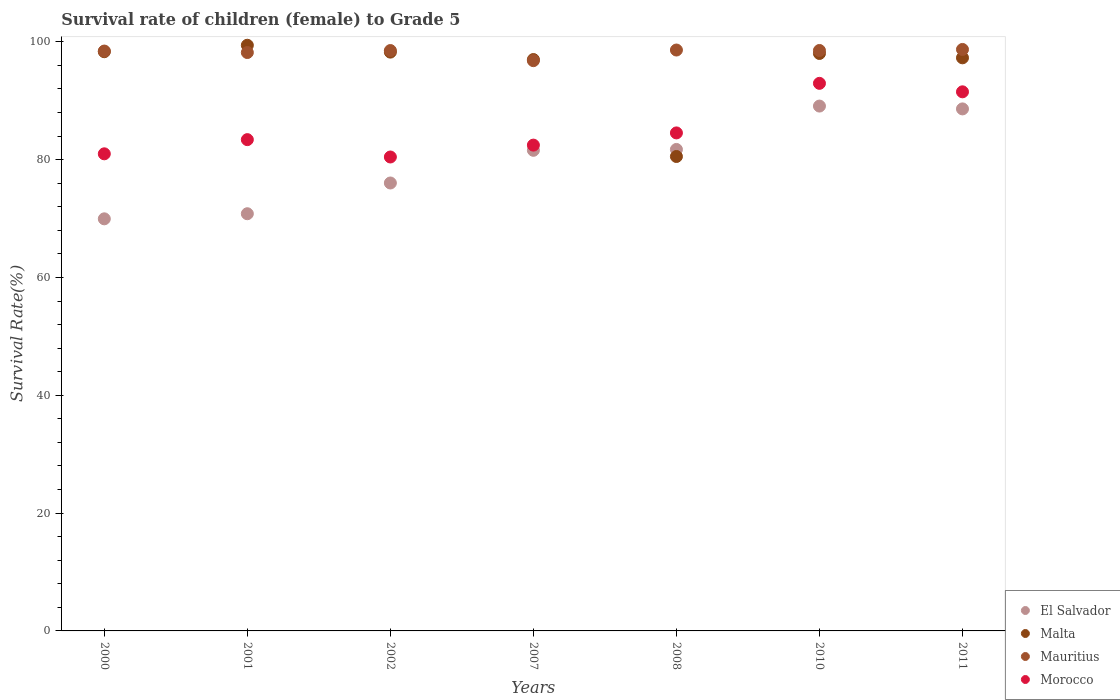How many different coloured dotlines are there?
Offer a terse response. 4. Is the number of dotlines equal to the number of legend labels?
Provide a short and direct response. Yes. What is the survival rate of female children to grade 5 in Mauritius in 2007?
Your response must be concise. 96.81. Across all years, what is the maximum survival rate of female children to grade 5 in Mauritius?
Ensure brevity in your answer.  98.71. Across all years, what is the minimum survival rate of female children to grade 5 in Morocco?
Provide a short and direct response. 80.45. In which year was the survival rate of female children to grade 5 in Malta minimum?
Your answer should be compact. 2008. What is the total survival rate of female children to grade 5 in Mauritius in the graph?
Give a very brief answer. 687.8. What is the difference between the survival rate of female children to grade 5 in Malta in 2000 and that in 2008?
Offer a terse response. 17.79. What is the difference between the survival rate of female children to grade 5 in Morocco in 2011 and the survival rate of female children to grade 5 in Malta in 2002?
Offer a very short reply. -6.74. What is the average survival rate of female children to grade 5 in Mauritius per year?
Make the answer very short. 98.26. In the year 2007, what is the difference between the survival rate of female children to grade 5 in El Salvador and survival rate of female children to grade 5 in Morocco?
Provide a short and direct response. -0.88. What is the ratio of the survival rate of female children to grade 5 in Mauritius in 2001 to that in 2008?
Give a very brief answer. 1. Is the difference between the survival rate of female children to grade 5 in El Salvador in 2007 and 2011 greater than the difference between the survival rate of female children to grade 5 in Morocco in 2007 and 2011?
Your response must be concise. Yes. What is the difference between the highest and the second highest survival rate of female children to grade 5 in Morocco?
Ensure brevity in your answer.  1.44. What is the difference between the highest and the lowest survival rate of female children to grade 5 in Malta?
Ensure brevity in your answer.  18.88. In how many years, is the survival rate of female children to grade 5 in Mauritius greater than the average survival rate of female children to grade 5 in Mauritius taken over all years?
Keep it short and to the point. 5. Is it the case that in every year, the sum of the survival rate of female children to grade 5 in Mauritius and survival rate of female children to grade 5 in El Salvador  is greater than the survival rate of female children to grade 5 in Malta?
Give a very brief answer. Yes. Is the survival rate of female children to grade 5 in Malta strictly greater than the survival rate of female children to grade 5 in Morocco over the years?
Offer a terse response. No. Is the survival rate of female children to grade 5 in Mauritius strictly less than the survival rate of female children to grade 5 in Morocco over the years?
Your answer should be compact. No. What is the difference between two consecutive major ticks on the Y-axis?
Ensure brevity in your answer.  20. Are the values on the major ticks of Y-axis written in scientific E-notation?
Ensure brevity in your answer.  No. Does the graph contain any zero values?
Keep it short and to the point. No. Where does the legend appear in the graph?
Your answer should be very brief. Bottom right. How many legend labels are there?
Make the answer very short. 4. What is the title of the graph?
Keep it short and to the point. Survival rate of children (female) to Grade 5. Does "Malawi" appear as one of the legend labels in the graph?
Your answer should be compact. No. What is the label or title of the X-axis?
Make the answer very short. Years. What is the label or title of the Y-axis?
Your answer should be compact. Survival Rate(%). What is the Survival Rate(%) in El Salvador in 2000?
Give a very brief answer. 69.95. What is the Survival Rate(%) in Malta in 2000?
Your answer should be compact. 98.32. What is the Survival Rate(%) in Mauritius in 2000?
Make the answer very short. 98.44. What is the Survival Rate(%) in Morocco in 2000?
Provide a succinct answer. 80.99. What is the Survival Rate(%) of El Salvador in 2001?
Provide a succinct answer. 70.82. What is the Survival Rate(%) in Malta in 2001?
Provide a succinct answer. 99.42. What is the Survival Rate(%) in Mauritius in 2001?
Your answer should be very brief. 98.19. What is the Survival Rate(%) in Morocco in 2001?
Offer a very short reply. 83.4. What is the Survival Rate(%) of El Salvador in 2002?
Ensure brevity in your answer.  76.04. What is the Survival Rate(%) of Malta in 2002?
Your response must be concise. 98.26. What is the Survival Rate(%) of Mauritius in 2002?
Give a very brief answer. 98.52. What is the Survival Rate(%) in Morocco in 2002?
Your response must be concise. 80.45. What is the Survival Rate(%) in El Salvador in 2007?
Provide a short and direct response. 81.59. What is the Survival Rate(%) of Malta in 2007?
Provide a succinct answer. 97. What is the Survival Rate(%) of Mauritius in 2007?
Make the answer very short. 96.81. What is the Survival Rate(%) of Morocco in 2007?
Make the answer very short. 82.47. What is the Survival Rate(%) in El Salvador in 2008?
Your answer should be very brief. 81.73. What is the Survival Rate(%) in Malta in 2008?
Provide a succinct answer. 80.54. What is the Survival Rate(%) in Mauritius in 2008?
Provide a succinct answer. 98.61. What is the Survival Rate(%) in Morocco in 2008?
Give a very brief answer. 84.54. What is the Survival Rate(%) in El Salvador in 2010?
Your answer should be very brief. 89.1. What is the Survival Rate(%) in Malta in 2010?
Your answer should be very brief. 98.03. What is the Survival Rate(%) in Mauritius in 2010?
Your response must be concise. 98.53. What is the Survival Rate(%) of Morocco in 2010?
Give a very brief answer. 92.95. What is the Survival Rate(%) of El Salvador in 2011?
Provide a short and direct response. 88.62. What is the Survival Rate(%) of Malta in 2011?
Ensure brevity in your answer.  97.29. What is the Survival Rate(%) in Mauritius in 2011?
Provide a succinct answer. 98.71. What is the Survival Rate(%) in Morocco in 2011?
Keep it short and to the point. 91.52. Across all years, what is the maximum Survival Rate(%) of El Salvador?
Your answer should be very brief. 89.1. Across all years, what is the maximum Survival Rate(%) of Malta?
Your answer should be very brief. 99.42. Across all years, what is the maximum Survival Rate(%) in Mauritius?
Your answer should be compact. 98.71. Across all years, what is the maximum Survival Rate(%) in Morocco?
Make the answer very short. 92.95. Across all years, what is the minimum Survival Rate(%) of El Salvador?
Provide a short and direct response. 69.95. Across all years, what is the minimum Survival Rate(%) in Malta?
Offer a very short reply. 80.54. Across all years, what is the minimum Survival Rate(%) in Mauritius?
Provide a succinct answer. 96.81. Across all years, what is the minimum Survival Rate(%) of Morocco?
Make the answer very short. 80.45. What is the total Survival Rate(%) of El Salvador in the graph?
Offer a very short reply. 557.84. What is the total Survival Rate(%) of Malta in the graph?
Your answer should be very brief. 668.84. What is the total Survival Rate(%) of Mauritius in the graph?
Keep it short and to the point. 687.8. What is the total Survival Rate(%) of Morocco in the graph?
Your answer should be compact. 596.32. What is the difference between the Survival Rate(%) of El Salvador in 2000 and that in 2001?
Ensure brevity in your answer.  -0.87. What is the difference between the Survival Rate(%) of Malta in 2000 and that in 2001?
Provide a succinct answer. -1.1. What is the difference between the Survival Rate(%) of Mauritius in 2000 and that in 2001?
Provide a short and direct response. 0.25. What is the difference between the Survival Rate(%) in Morocco in 2000 and that in 2001?
Your response must be concise. -2.41. What is the difference between the Survival Rate(%) of El Salvador in 2000 and that in 2002?
Your answer should be very brief. -6.08. What is the difference between the Survival Rate(%) of Malta in 2000 and that in 2002?
Provide a short and direct response. 0.07. What is the difference between the Survival Rate(%) in Mauritius in 2000 and that in 2002?
Offer a terse response. -0.09. What is the difference between the Survival Rate(%) of Morocco in 2000 and that in 2002?
Keep it short and to the point. 0.54. What is the difference between the Survival Rate(%) of El Salvador in 2000 and that in 2007?
Your answer should be compact. -11.63. What is the difference between the Survival Rate(%) of Malta in 2000 and that in 2007?
Provide a short and direct response. 1.33. What is the difference between the Survival Rate(%) of Mauritius in 2000 and that in 2007?
Your answer should be very brief. 1.63. What is the difference between the Survival Rate(%) in Morocco in 2000 and that in 2007?
Make the answer very short. -1.48. What is the difference between the Survival Rate(%) in El Salvador in 2000 and that in 2008?
Offer a terse response. -11.78. What is the difference between the Survival Rate(%) in Malta in 2000 and that in 2008?
Make the answer very short. 17.79. What is the difference between the Survival Rate(%) in Mauritius in 2000 and that in 2008?
Your answer should be very brief. -0.17. What is the difference between the Survival Rate(%) in Morocco in 2000 and that in 2008?
Provide a succinct answer. -3.55. What is the difference between the Survival Rate(%) of El Salvador in 2000 and that in 2010?
Ensure brevity in your answer.  -19.14. What is the difference between the Survival Rate(%) in Malta in 2000 and that in 2010?
Your answer should be compact. 0.3. What is the difference between the Survival Rate(%) in Mauritius in 2000 and that in 2010?
Offer a very short reply. -0.1. What is the difference between the Survival Rate(%) of Morocco in 2000 and that in 2010?
Ensure brevity in your answer.  -11.96. What is the difference between the Survival Rate(%) in El Salvador in 2000 and that in 2011?
Ensure brevity in your answer.  -18.66. What is the difference between the Survival Rate(%) of Malta in 2000 and that in 2011?
Provide a short and direct response. 1.04. What is the difference between the Survival Rate(%) of Mauritius in 2000 and that in 2011?
Offer a terse response. -0.27. What is the difference between the Survival Rate(%) in Morocco in 2000 and that in 2011?
Make the answer very short. -10.52. What is the difference between the Survival Rate(%) in El Salvador in 2001 and that in 2002?
Offer a terse response. -5.22. What is the difference between the Survival Rate(%) in Malta in 2001 and that in 2002?
Offer a very short reply. 1.16. What is the difference between the Survival Rate(%) in Mauritius in 2001 and that in 2002?
Provide a short and direct response. -0.34. What is the difference between the Survival Rate(%) of Morocco in 2001 and that in 2002?
Your response must be concise. 2.95. What is the difference between the Survival Rate(%) in El Salvador in 2001 and that in 2007?
Provide a short and direct response. -10.77. What is the difference between the Survival Rate(%) of Malta in 2001 and that in 2007?
Your answer should be very brief. 2.42. What is the difference between the Survival Rate(%) of Mauritius in 2001 and that in 2007?
Offer a terse response. 1.38. What is the difference between the Survival Rate(%) of Morocco in 2001 and that in 2007?
Give a very brief answer. 0.93. What is the difference between the Survival Rate(%) in El Salvador in 2001 and that in 2008?
Offer a terse response. -10.91. What is the difference between the Survival Rate(%) of Malta in 2001 and that in 2008?
Your response must be concise. 18.88. What is the difference between the Survival Rate(%) in Mauritius in 2001 and that in 2008?
Provide a short and direct response. -0.42. What is the difference between the Survival Rate(%) of Morocco in 2001 and that in 2008?
Keep it short and to the point. -1.14. What is the difference between the Survival Rate(%) of El Salvador in 2001 and that in 2010?
Provide a short and direct response. -18.28. What is the difference between the Survival Rate(%) in Malta in 2001 and that in 2010?
Make the answer very short. 1.4. What is the difference between the Survival Rate(%) in Mauritius in 2001 and that in 2010?
Give a very brief answer. -0.35. What is the difference between the Survival Rate(%) of Morocco in 2001 and that in 2010?
Provide a short and direct response. -9.56. What is the difference between the Survival Rate(%) in El Salvador in 2001 and that in 2011?
Keep it short and to the point. -17.8. What is the difference between the Survival Rate(%) of Malta in 2001 and that in 2011?
Keep it short and to the point. 2.13. What is the difference between the Survival Rate(%) in Mauritius in 2001 and that in 2011?
Ensure brevity in your answer.  -0.52. What is the difference between the Survival Rate(%) in Morocco in 2001 and that in 2011?
Your answer should be very brief. -8.12. What is the difference between the Survival Rate(%) in El Salvador in 2002 and that in 2007?
Offer a terse response. -5.55. What is the difference between the Survival Rate(%) in Malta in 2002 and that in 2007?
Your response must be concise. 1.26. What is the difference between the Survival Rate(%) of Mauritius in 2002 and that in 2007?
Provide a short and direct response. 1.72. What is the difference between the Survival Rate(%) in Morocco in 2002 and that in 2007?
Ensure brevity in your answer.  -2.02. What is the difference between the Survival Rate(%) in El Salvador in 2002 and that in 2008?
Ensure brevity in your answer.  -5.69. What is the difference between the Survival Rate(%) of Malta in 2002 and that in 2008?
Your answer should be very brief. 17.72. What is the difference between the Survival Rate(%) in Mauritius in 2002 and that in 2008?
Your answer should be very brief. -0.09. What is the difference between the Survival Rate(%) of Morocco in 2002 and that in 2008?
Offer a terse response. -4.09. What is the difference between the Survival Rate(%) in El Salvador in 2002 and that in 2010?
Your answer should be very brief. -13.06. What is the difference between the Survival Rate(%) of Malta in 2002 and that in 2010?
Offer a terse response. 0.23. What is the difference between the Survival Rate(%) in Mauritius in 2002 and that in 2010?
Give a very brief answer. -0.01. What is the difference between the Survival Rate(%) of Morocco in 2002 and that in 2010?
Offer a terse response. -12.5. What is the difference between the Survival Rate(%) in El Salvador in 2002 and that in 2011?
Provide a short and direct response. -12.58. What is the difference between the Survival Rate(%) of Malta in 2002 and that in 2011?
Offer a terse response. 0.97. What is the difference between the Survival Rate(%) in Mauritius in 2002 and that in 2011?
Provide a short and direct response. -0.19. What is the difference between the Survival Rate(%) of Morocco in 2002 and that in 2011?
Make the answer very short. -11.06. What is the difference between the Survival Rate(%) in El Salvador in 2007 and that in 2008?
Keep it short and to the point. -0.15. What is the difference between the Survival Rate(%) of Malta in 2007 and that in 2008?
Your answer should be compact. 16.46. What is the difference between the Survival Rate(%) in Mauritius in 2007 and that in 2008?
Your answer should be very brief. -1.8. What is the difference between the Survival Rate(%) of Morocco in 2007 and that in 2008?
Keep it short and to the point. -2.07. What is the difference between the Survival Rate(%) of El Salvador in 2007 and that in 2010?
Give a very brief answer. -7.51. What is the difference between the Survival Rate(%) of Malta in 2007 and that in 2010?
Your answer should be compact. -1.03. What is the difference between the Survival Rate(%) in Mauritius in 2007 and that in 2010?
Provide a short and direct response. -1.73. What is the difference between the Survival Rate(%) in Morocco in 2007 and that in 2010?
Offer a terse response. -10.49. What is the difference between the Survival Rate(%) of El Salvador in 2007 and that in 2011?
Your answer should be compact. -7.03. What is the difference between the Survival Rate(%) in Malta in 2007 and that in 2011?
Provide a succinct answer. -0.29. What is the difference between the Survival Rate(%) in Mauritius in 2007 and that in 2011?
Your answer should be very brief. -1.9. What is the difference between the Survival Rate(%) of Morocco in 2007 and that in 2011?
Provide a short and direct response. -9.05. What is the difference between the Survival Rate(%) of El Salvador in 2008 and that in 2010?
Keep it short and to the point. -7.36. What is the difference between the Survival Rate(%) of Malta in 2008 and that in 2010?
Give a very brief answer. -17.49. What is the difference between the Survival Rate(%) of Mauritius in 2008 and that in 2010?
Your response must be concise. 0.08. What is the difference between the Survival Rate(%) in Morocco in 2008 and that in 2010?
Offer a terse response. -8.42. What is the difference between the Survival Rate(%) of El Salvador in 2008 and that in 2011?
Make the answer very short. -6.88. What is the difference between the Survival Rate(%) in Malta in 2008 and that in 2011?
Your answer should be compact. -16.75. What is the difference between the Survival Rate(%) in Mauritius in 2008 and that in 2011?
Keep it short and to the point. -0.1. What is the difference between the Survival Rate(%) in Morocco in 2008 and that in 2011?
Your response must be concise. -6.98. What is the difference between the Survival Rate(%) in El Salvador in 2010 and that in 2011?
Give a very brief answer. 0.48. What is the difference between the Survival Rate(%) of Malta in 2010 and that in 2011?
Keep it short and to the point. 0.74. What is the difference between the Survival Rate(%) in Mauritius in 2010 and that in 2011?
Your answer should be very brief. -0.17. What is the difference between the Survival Rate(%) in Morocco in 2010 and that in 2011?
Provide a short and direct response. 1.44. What is the difference between the Survival Rate(%) of El Salvador in 2000 and the Survival Rate(%) of Malta in 2001?
Provide a succinct answer. -29.47. What is the difference between the Survival Rate(%) of El Salvador in 2000 and the Survival Rate(%) of Mauritius in 2001?
Give a very brief answer. -28.23. What is the difference between the Survival Rate(%) of El Salvador in 2000 and the Survival Rate(%) of Morocco in 2001?
Keep it short and to the point. -13.44. What is the difference between the Survival Rate(%) in Malta in 2000 and the Survival Rate(%) in Mauritius in 2001?
Your response must be concise. 0.14. What is the difference between the Survival Rate(%) in Malta in 2000 and the Survival Rate(%) in Morocco in 2001?
Offer a terse response. 14.92. What is the difference between the Survival Rate(%) of Mauritius in 2000 and the Survival Rate(%) of Morocco in 2001?
Your answer should be very brief. 15.04. What is the difference between the Survival Rate(%) in El Salvador in 2000 and the Survival Rate(%) in Malta in 2002?
Your response must be concise. -28.3. What is the difference between the Survival Rate(%) in El Salvador in 2000 and the Survival Rate(%) in Mauritius in 2002?
Keep it short and to the point. -28.57. What is the difference between the Survival Rate(%) in El Salvador in 2000 and the Survival Rate(%) in Morocco in 2002?
Give a very brief answer. -10.5. What is the difference between the Survival Rate(%) of Malta in 2000 and the Survival Rate(%) of Mauritius in 2002?
Provide a succinct answer. -0.2. What is the difference between the Survival Rate(%) in Malta in 2000 and the Survival Rate(%) in Morocco in 2002?
Your answer should be compact. 17.87. What is the difference between the Survival Rate(%) in Mauritius in 2000 and the Survival Rate(%) in Morocco in 2002?
Provide a succinct answer. 17.98. What is the difference between the Survival Rate(%) in El Salvador in 2000 and the Survival Rate(%) in Malta in 2007?
Your answer should be compact. -27.04. What is the difference between the Survival Rate(%) of El Salvador in 2000 and the Survival Rate(%) of Mauritius in 2007?
Provide a short and direct response. -26.85. What is the difference between the Survival Rate(%) of El Salvador in 2000 and the Survival Rate(%) of Morocco in 2007?
Your answer should be compact. -12.51. What is the difference between the Survival Rate(%) of Malta in 2000 and the Survival Rate(%) of Mauritius in 2007?
Your answer should be compact. 1.52. What is the difference between the Survival Rate(%) in Malta in 2000 and the Survival Rate(%) in Morocco in 2007?
Your response must be concise. 15.86. What is the difference between the Survival Rate(%) in Mauritius in 2000 and the Survival Rate(%) in Morocco in 2007?
Your answer should be compact. 15.97. What is the difference between the Survival Rate(%) of El Salvador in 2000 and the Survival Rate(%) of Malta in 2008?
Ensure brevity in your answer.  -10.58. What is the difference between the Survival Rate(%) of El Salvador in 2000 and the Survival Rate(%) of Mauritius in 2008?
Give a very brief answer. -28.65. What is the difference between the Survival Rate(%) of El Salvador in 2000 and the Survival Rate(%) of Morocco in 2008?
Keep it short and to the point. -14.58. What is the difference between the Survival Rate(%) in Malta in 2000 and the Survival Rate(%) in Mauritius in 2008?
Provide a succinct answer. -0.29. What is the difference between the Survival Rate(%) in Malta in 2000 and the Survival Rate(%) in Morocco in 2008?
Give a very brief answer. 13.78. What is the difference between the Survival Rate(%) in Mauritius in 2000 and the Survival Rate(%) in Morocco in 2008?
Give a very brief answer. 13.9. What is the difference between the Survival Rate(%) of El Salvador in 2000 and the Survival Rate(%) of Malta in 2010?
Make the answer very short. -28.07. What is the difference between the Survival Rate(%) of El Salvador in 2000 and the Survival Rate(%) of Mauritius in 2010?
Your answer should be very brief. -28.58. What is the difference between the Survival Rate(%) of El Salvador in 2000 and the Survival Rate(%) of Morocco in 2010?
Provide a succinct answer. -23. What is the difference between the Survival Rate(%) of Malta in 2000 and the Survival Rate(%) of Mauritius in 2010?
Offer a very short reply. -0.21. What is the difference between the Survival Rate(%) of Malta in 2000 and the Survival Rate(%) of Morocco in 2010?
Make the answer very short. 5.37. What is the difference between the Survival Rate(%) of Mauritius in 2000 and the Survival Rate(%) of Morocco in 2010?
Your answer should be compact. 5.48. What is the difference between the Survival Rate(%) of El Salvador in 2000 and the Survival Rate(%) of Malta in 2011?
Make the answer very short. -27.33. What is the difference between the Survival Rate(%) of El Salvador in 2000 and the Survival Rate(%) of Mauritius in 2011?
Ensure brevity in your answer.  -28.75. What is the difference between the Survival Rate(%) of El Salvador in 2000 and the Survival Rate(%) of Morocco in 2011?
Provide a short and direct response. -21.56. What is the difference between the Survival Rate(%) of Malta in 2000 and the Survival Rate(%) of Mauritius in 2011?
Provide a succinct answer. -0.38. What is the difference between the Survival Rate(%) of Malta in 2000 and the Survival Rate(%) of Morocco in 2011?
Your response must be concise. 6.81. What is the difference between the Survival Rate(%) of Mauritius in 2000 and the Survival Rate(%) of Morocco in 2011?
Offer a terse response. 6.92. What is the difference between the Survival Rate(%) in El Salvador in 2001 and the Survival Rate(%) in Malta in 2002?
Provide a short and direct response. -27.44. What is the difference between the Survival Rate(%) in El Salvador in 2001 and the Survival Rate(%) in Mauritius in 2002?
Offer a terse response. -27.7. What is the difference between the Survival Rate(%) in El Salvador in 2001 and the Survival Rate(%) in Morocco in 2002?
Offer a very short reply. -9.63. What is the difference between the Survival Rate(%) of Malta in 2001 and the Survival Rate(%) of Mauritius in 2002?
Keep it short and to the point. 0.9. What is the difference between the Survival Rate(%) of Malta in 2001 and the Survival Rate(%) of Morocco in 2002?
Keep it short and to the point. 18.97. What is the difference between the Survival Rate(%) in Mauritius in 2001 and the Survival Rate(%) in Morocco in 2002?
Offer a terse response. 17.73. What is the difference between the Survival Rate(%) of El Salvador in 2001 and the Survival Rate(%) of Malta in 2007?
Provide a short and direct response. -26.18. What is the difference between the Survival Rate(%) in El Salvador in 2001 and the Survival Rate(%) in Mauritius in 2007?
Your response must be concise. -25.99. What is the difference between the Survival Rate(%) in El Salvador in 2001 and the Survival Rate(%) in Morocco in 2007?
Your answer should be very brief. -11.65. What is the difference between the Survival Rate(%) of Malta in 2001 and the Survival Rate(%) of Mauritius in 2007?
Your response must be concise. 2.61. What is the difference between the Survival Rate(%) in Malta in 2001 and the Survival Rate(%) in Morocco in 2007?
Provide a short and direct response. 16.95. What is the difference between the Survival Rate(%) in Mauritius in 2001 and the Survival Rate(%) in Morocco in 2007?
Your answer should be very brief. 15.72. What is the difference between the Survival Rate(%) of El Salvador in 2001 and the Survival Rate(%) of Malta in 2008?
Your answer should be compact. -9.72. What is the difference between the Survival Rate(%) of El Salvador in 2001 and the Survival Rate(%) of Mauritius in 2008?
Provide a succinct answer. -27.79. What is the difference between the Survival Rate(%) in El Salvador in 2001 and the Survival Rate(%) in Morocco in 2008?
Ensure brevity in your answer.  -13.72. What is the difference between the Survival Rate(%) of Malta in 2001 and the Survival Rate(%) of Mauritius in 2008?
Provide a succinct answer. 0.81. What is the difference between the Survival Rate(%) in Malta in 2001 and the Survival Rate(%) in Morocco in 2008?
Your response must be concise. 14.88. What is the difference between the Survival Rate(%) of Mauritius in 2001 and the Survival Rate(%) of Morocco in 2008?
Your answer should be compact. 13.65. What is the difference between the Survival Rate(%) in El Salvador in 2001 and the Survival Rate(%) in Malta in 2010?
Provide a succinct answer. -27.21. What is the difference between the Survival Rate(%) in El Salvador in 2001 and the Survival Rate(%) in Mauritius in 2010?
Give a very brief answer. -27.71. What is the difference between the Survival Rate(%) in El Salvador in 2001 and the Survival Rate(%) in Morocco in 2010?
Provide a succinct answer. -22.13. What is the difference between the Survival Rate(%) of Malta in 2001 and the Survival Rate(%) of Mauritius in 2010?
Give a very brief answer. 0.89. What is the difference between the Survival Rate(%) in Malta in 2001 and the Survival Rate(%) in Morocco in 2010?
Your answer should be compact. 6.47. What is the difference between the Survival Rate(%) in Mauritius in 2001 and the Survival Rate(%) in Morocco in 2010?
Your answer should be compact. 5.23. What is the difference between the Survival Rate(%) in El Salvador in 2001 and the Survival Rate(%) in Malta in 2011?
Offer a terse response. -26.47. What is the difference between the Survival Rate(%) of El Salvador in 2001 and the Survival Rate(%) of Mauritius in 2011?
Your response must be concise. -27.89. What is the difference between the Survival Rate(%) in El Salvador in 2001 and the Survival Rate(%) in Morocco in 2011?
Make the answer very short. -20.7. What is the difference between the Survival Rate(%) of Malta in 2001 and the Survival Rate(%) of Mauritius in 2011?
Ensure brevity in your answer.  0.71. What is the difference between the Survival Rate(%) in Malta in 2001 and the Survival Rate(%) in Morocco in 2011?
Provide a short and direct response. 7.91. What is the difference between the Survival Rate(%) in Mauritius in 2001 and the Survival Rate(%) in Morocco in 2011?
Provide a short and direct response. 6.67. What is the difference between the Survival Rate(%) of El Salvador in 2002 and the Survival Rate(%) of Malta in 2007?
Keep it short and to the point. -20.96. What is the difference between the Survival Rate(%) in El Salvador in 2002 and the Survival Rate(%) in Mauritius in 2007?
Your answer should be compact. -20.77. What is the difference between the Survival Rate(%) of El Salvador in 2002 and the Survival Rate(%) of Morocco in 2007?
Keep it short and to the point. -6.43. What is the difference between the Survival Rate(%) of Malta in 2002 and the Survival Rate(%) of Mauritius in 2007?
Offer a very short reply. 1.45. What is the difference between the Survival Rate(%) of Malta in 2002 and the Survival Rate(%) of Morocco in 2007?
Your answer should be very brief. 15.79. What is the difference between the Survival Rate(%) of Mauritius in 2002 and the Survival Rate(%) of Morocco in 2007?
Offer a terse response. 16.05. What is the difference between the Survival Rate(%) of El Salvador in 2002 and the Survival Rate(%) of Malta in 2008?
Make the answer very short. -4.5. What is the difference between the Survival Rate(%) in El Salvador in 2002 and the Survival Rate(%) in Mauritius in 2008?
Offer a terse response. -22.57. What is the difference between the Survival Rate(%) of El Salvador in 2002 and the Survival Rate(%) of Morocco in 2008?
Your answer should be compact. -8.5. What is the difference between the Survival Rate(%) in Malta in 2002 and the Survival Rate(%) in Mauritius in 2008?
Make the answer very short. -0.35. What is the difference between the Survival Rate(%) in Malta in 2002 and the Survival Rate(%) in Morocco in 2008?
Your answer should be very brief. 13.72. What is the difference between the Survival Rate(%) of Mauritius in 2002 and the Survival Rate(%) of Morocco in 2008?
Your answer should be very brief. 13.98. What is the difference between the Survival Rate(%) in El Salvador in 2002 and the Survival Rate(%) in Malta in 2010?
Ensure brevity in your answer.  -21.99. What is the difference between the Survival Rate(%) of El Salvador in 2002 and the Survival Rate(%) of Mauritius in 2010?
Make the answer very short. -22.5. What is the difference between the Survival Rate(%) of El Salvador in 2002 and the Survival Rate(%) of Morocco in 2010?
Ensure brevity in your answer.  -16.92. What is the difference between the Survival Rate(%) in Malta in 2002 and the Survival Rate(%) in Mauritius in 2010?
Your answer should be compact. -0.28. What is the difference between the Survival Rate(%) of Malta in 2002 and the Survival Rate(%) of Morocco in 2010?
Provide a short and direct response. 5.3. What is the difference between the Survival Rate(%) of Mauritius in 2002 and the Survival Rate(%) of Morocco in 2010?
Your response must be concise. 5.57. What is the difference between the Survival Rate(%) of El Salvador in 2002 and the Survival Rate(%) of Malta in 2011?
Keep it short and to the point. -21.25. What is the difference between the Survival Rate(%) in El Salvador in 2002 and the Survival Rate(%) in Mauritius in 2011?
Your answer should be compact. -22.67. What is the difference between the Survival Rate(%) in El Salvador in 2002 and the Survival Rate(%) in Morocco in 2011?
Offer a very short reply. -15.48. What is the difference between the Survival Rate(%) of Malta in 2002 and the Survival Rate(%) of Mauritius in 2011?
Your answer should be very brief. -0.45. What is the difference between the Survival Rate(%) of Malta in 2002 and the Survival Rate(%) of Morocco in 2011?
Your answer should be very brief. 6.74. What is the difference between the Survival Rate(%) in Mauritius in 2002 and the Survival Rate(%) in Morocco in 2011?
Provide a short and direct response. 7.01. What is the difference between the Survival Rate(%) of El Salvador in 2007 and the Survival Rate(%) of Malta in 2008?
Your answer should be compact. 1.05. What is the difference between the Survival Rate(%) of El Salvador in 2007 and the Survival Rate(%) of Mauritius in 2008?
Keep it short and to the point. -17.02. What is the difference between the Survival Rate(%) in El Salvador in 2007 and the Survival Rate(%) in Morocco in 2008?
Your answer should be very brief. -2.95. What is the difference between the Survival Rate(%) of Malta in 2007 and the Survival Rate(%) of Mauritius in 2008?
Offer a very short reply. -1.61. What is the difference between the Survival Rate(%) in Malta in 2007 and the Survival Rate(%) in Morocco in 2008?
Offer a very short reply. 12.46. What is the difference between the Survival Rate(%) in Mauritius in 2007 and the Survival Rate(%) in Morocco in 2008?
Make the answer very short. 12.27. What is the difference between the Survival Rate(%) in El Salvador in 2007 and the Survival Rate(%) in Malta in 2010?
Ensure brevity in your answer.  -16.44. What is the difference between the Survival Rate(%) of El Salvador in 2007 and the Survival Rate(%) of Mauritius in 2010?
Ensure brevity in your answer.  -16.95. What is the difference between the Survival Rate(%) of El Salvador in 2007 and the Survival Rate(%) of Morocco in 2010?
Provide a short and direct response. -11.37. What is the difference between the Survival Rate(%) of Malta in 2007 and the Survival Rate(%) of Mauritius in 2010?
Your response must be concise. -1.54. What is the difference between the Survival Rate(%) in Malta in 2007 and the Survival Rate(%) in Morocco in 2010?
Keep it short and to the point. 4.04. What is the difference between the Survival Rate(%) of Mauritius in 2007 and the Survival Rate(%) of Morocco in 2010?
Ensure brevity in your answer.  3.85. What is the difference between the Survival Rate(%) in El Salvador in 2007 and the Survival Rate(%) in Malta in 2011?
Keep it short and to the point. -15.7. What is the difference between the Survival Rate(%) in El Salvador in 2007 and the Survival Rate(%) in Mauritius in 2011?
Provide a short and direct response. -17.12. What is the difference between the Survival Rate(%) of El Salvador in 2007 and the Survival Rate(%) of Morocco in 2011?
Offer a very short reply. -9.93. What is the difference between the Survival Rate(%) of Malta in 2007 and the Survival Rate(%) of Mauritius in 2011?
Your answer should be compact. -1.71. What is the difference between the Survival Rate(%) of Malta in 2007 and the Survival Rate(%) of Morocco in 2011?
Make the answer very short. 5.48. What is the difference between the Survival Rate(%) of Mauritius in 2007 and the Survival Rate(%) of Morocco in 2011?
Your response must be concise. 5.29. What is the difference between the Survival Rate(%) of El Salvador in 2008 and the Survival Rate(%) of Malta in 2010?
Give a very brief answer. -16.29. What is the difference between the Survival Rate(%) of El Salvador in 2008 and the Survival Rate(%) of Mauritius in 2010?
Offer a terse response. -16.8. What is the difference between the Survival Rate(%) in El Salvador in 2008 and the Survival Rate(%) in Morocco in 2010?
Offer a very short reply. -11.22. What is the difference between the Survival Rate(%) of Malta in 2008 and the Survival Rate(%) of Mauritius in 2010?
Offer a very short reply. -18. What is the difference between the Survival Rate(%) in Malta in 2008 and the Survival Rate(%) in Morocco in 2010?
Provide a succinct answer. -12.42. What is the difference between the Survival Rate(%) of Mauritius in 2008 and the Survival Rate(%) of Morocco in 2010?
Your answer should be compact. 5.66. What is the difference between the Survival Rate(%) of El Salvador in 2008 and the Survival Rate(%) of Malta in 2011?
Make the answer very short. -15.55. What is the difference between the Survival Rate(%) in El Salvador in 2008 and the Survival Rate(%) in Mauritius in 2011?
Provide a succinct answer. -16.98. What is the difference between the Survival Rate(%) of El Salvador in 2008 and the Survival Rate(%) of Morocco in 2011?
Offer a very short reply. -9.78. What is the difference between the Survival Rate(%) in Malta in 2008 and the Survival Rate(%) in Mauritius in 2011?
Keep it short and to the point. -18.17. What is the difference between the Survival Rate(%) in Malta in 2008 and the Survival Rate(%) in Morocco in 2011?
Your answer should be very brief. -10.98. What is the difference between the Survival Rate(%) in Mauritius in 2008 and the Survival Rate(%) in Morocco in 2011?
Your response must be concise. 7.09. What is the difference between the Survival Rate(%) in El Salvador in 2010 and the Survival Rate(%) in Malta in 2011?
Provide a succinct answer. -8.19. What is the difference between the Survival Rate(%) in El Salvador in 2010 and the Survival Rate(%) in Mauritius in 2011?
Give a very brief answer. -9.61. What is the difference between the Survival Rate(%) of El Salvador in 2010 and the Survival Rate(%) of Morocco in 2011?
Your response must be concise. -2.42. What is the difference between the Survival Rate(%) in Malta in 2010 and the Survival Rate(%) in Mauritius in 2011?
Your answer should be compact. -0.68. What is the difference between the Survival Rate(%) in Malta in 2010 and the Survival Rate(%) in Morocco in 2011?
Provide a succinct answer. 6.51. What is the difference between the Survival Rate(%) in Mauritius in 2010 and the Survival Rate(%) in Morocco in 2011?
Give a very brief answer. 7.02. What is the average Survival Rate(%) of El Salvador per year?
Make the answer very short. 79.69. What is the average Survival Rate(%) of Malta per year?
Ensure brevity in your answer.  95.55. What is the average Survival Rate(%) of Mauritius per year?
Ensure brevity in your answer.  98.26. What is the average Survival Rate(%) in Morocco per year?
Give a very brief answer. 85.19. In the year 2000, what is the difference between the Survival Rate(%) of El Salvador and Survival Rate(%) of Malta?
Provide a short and direct response. -28.37. In the year 2000, what is the difference between the Survival Rate(%) of El Salvador and Survival Rate(%) of Mauritius?
Your answer should be very brief. -28.48. In the year 2000, what is the difference between the Survival Rate(%) of El Salvador and Survival Rate(%) of Morocco?
Your answer should be very brief. -11.04. In the year 2000, what is the difference between the Survival Rate(%) in Malta and Survival Rate(%) in Mauritius?
Keep it short and to the point. -0.11. In the year 2000, what is the difference between the Survival Rate(%) of Malta and Survival Rate(%) of Morocco?
Make the answer very short. 17.33. In the year 2000, what is the difference between the Survival Rate(%) in Mauritius and Survival Rate(%) in Morocco?
Offer a very short reply. 17.45. In the year 2001, what is the difference between the Survival Rate(%) in El Salvador and Survival Rate(%) in Malta?
Make the answer very short. -28.6. In the year 2001, what is the difference between the Survival Rate(%) in El Salvador and Survival Rate(%) in Mauritius?
Give a very brief answer. -27.37. In the year 2001, what is the difference between the Survival Rate(%) in El Salvador and Survival Rate(%) in Morocco?
Provide a succinct answer. -12.58. In the year 2001, what is the difference between the Survival Rate(%) of Malta and Survival Rate(%) of Mauritius?
Offer a very short reply. 1.24. In the year 2001, what is the difference between the Survival Rate(%) in Malta and Survival Rate(%) in Morocco?
Provide a succinct answer. 16.02. In the year 2001, what is the difference between the Survival Rate(%) in Mauritius and Survival Rate(%) in Morocco?
Your response must be concise. 14.79. In the year 2002, what is the difference between the Survival Rate(%) of El Salvador and Survival Rate(%) of Malta?
Keep it short and to the point. -22.22. In the year 2002, what is the difference between the Survival Rate(%) of El Salvador and Survival Rate(%) of Mauritius?
Provide a succinct answer. -22.48. In the year 2002, what is the difference between the Survival Rate(%) in El Salvador and Survival Rate(%) in Morocco?
Provide a short and direct response. -4.41. In the year 2002, what is the difference between the Survival Rate(%) in Malta and Survival Rate(%) in Mauritius?
Keep it short and to the point. -0.27. In the year 2002, what is the difference between the Survival Rate(%) in Malta and Survival Rate(%) in Morocco?
Offer a terse response. 17.8. In the year 2002, what is the difference between the Survival Rate(%) of Mauritius and Survival Rate(%) of Morocco?
Your answer should be very brief. 18.07. In the year 2007, what is the difference between the Survival Rate(%) of El Salvador and Survival Rate(%) of Malta?
Provide a succinct answer. -15.41. In the year 2007, what is the difference between the Survival Rate(%) in El Salvador and Survival Rate(%) in Mauritius?
Provide a succinct answer. -15.22. In the year 2007, what is the difference between the Survival Rate(%) in El Salvador and Survival Rate(%) in Morocco?
Keep it short and to the point. -0.88. In the year 2007, what is the difference between the Survival Rate(%) in Malta and Survival Rate(%) in Mauritius?
Keep it short and to the point. 0.19. In the year 2007, what is the difference between the Survival Rate(%) of Malta and Survival Rate(%) of Morocco?
Your response must be concise. 14.53. In the year 2007, what is the difference between the Survival Rate(%) of Mauritius and Survival Rate(%) of Morocco?
Your answer should be compact. 14.34. In the year 2008, what is the difference between the Survival Rate(%) of El Salvador and Survival Rate(%) of Malta?
Your answer should be very brief. 1.2. In the year 2008, what is the difference between the Survival Rate(%) of El Salvador and Survival Rate(%) of Mauritius?
Your answer should be very brief. -16.88. In the year 2008, what is the difference between the Survival Rate(%) of El Salvador and Survival Rate(%) of Morocco?
Give a very brief answer. -2.81. In the year 2008, what is the difference between the Survival Rate(%) in Malta and Survival Rate(%) in Mauritius?
Offer a terse response. -18.07. In the year 2008, what is the difference between the Survival Rate(%) in Malta and Survival Rate(%) in Morocco?
Offer a very short reply. -4. In the year 2008, what is the difference between the Survival Rate(%) in Mauritius and Survival Rate(%) in Morocco?
Give a very brief answer. 14.07. In the year 2010, what is the difference between the Survival Rate(%) of El Salvador and Survival Rate(%) of Malta?
Give a very brief answer. -8.93. In the year 2010, what is the difference between the Survival Rate(%) in El Salvador and Survival Rate(%) in Mauritius?
Give a very brief answer. -9.44. In the year 2010, what is the difference between the Survival Rate(%) in El Salvador and Survival Rate(%) in Morocco?
Offer a very short reply. -3.86. In the year 2010, what is the difference between the Survival Rate(%) in Malta and Survival Rate(%) in Mauritius?
Offer a very short reply. -0.51. In the year 2010, what is the difference between the Survival Rate(%) in Malta and Survival Rate(%) in Morocco?
Offer a very short reply. 5.07. In the year 2010, what is the difference between the Survival Rate(%) of Mauritius and Survival Rate(%) of Morocco?
Your answer should be very brief. 5.58. In the year 2011, what is the difference between the Survival Rate(%) in El Salvador and Survival Rate(%) in Malta?
Keep it short and to the point. -8.67. In the year 2011, what is the difference between the Survival Rate(%) of El Salvador and Survival Rate(%) of Mauritius?
Keep it short and to the point. -10.09. In the year 2011, what is the difference between the Survival Rate(%) of El Salvador and Survival Rate(%) of Morocco?
Give a very brief answer. -2.9. In the year 2011, what is the difference between the Survival Rate(%) of Malta and Survival Rate(%) of Mauritius?
Your response must be concise. -1.42. In the year 2011, what is the difference between the Survival Rate(%) of Malta and Survival Rate(%) of Morocco?
Your response must be concise. 5.77. In the year 2011, what is the difference between the Survival Rate(%) in Mauritius and Survival Rate(%) in Morocco?
Make the answer very short. 7.19. What is the ratio of the Survival Rate(%) of El Salvador in 2000 to that in 2001?
Offer a terse response. 0.99. What is the ratio of the Survival Rate(%) in Malta in 2000 to that in 2001?
Offer a terse response. 0.99. What is the ratio of the Survival Rate(%) of Morocco in 2000 to that in 2001?
Provide a succinct answer. 0.97. What is the ratio of the Survival Rate(%) in Malta in 2000 to that in 2002?
Your answer should be compact. 1. What is the ratio of the Survival Rate(%) of Morocco in 2000 to that in 2002?
Your answer should be very brief. 1.01. What is the ratio of the Survival Rate(%) of El Salvador in 2000 to that in 2007?
Keep it short and to the point. 0.86. What is the ratio of the Survival Rate(%) in Malta in 2000 to that in 2007?
Ensure brevity in your answer.  1.01. What is the ratio of the Survival Rate(%) of Mauritius in 2000 to that in 2007?
Make the answer very short. 1.02. What is the ratio of the Survival Rate(%) in Morocco in 2000 to that in 2007?
Make the answer very short. 0.98. What is the ratio of the Survival Rate(%) in El Salvador in 2000 to that in 2008?
Offer a terse response. 0.86. What is the ratio of the Survival Rate(%) in Malta in 2000 to that in 2008?
Your response must be concise. 1.22. What is the ratio of the Survival Rate(%) in Morocco in 2000 to that in 2008?
Your response must be concise. 0.96. What is the ratio of the Survival Rate(%) in El Salvador in 2000 to that in 2010?
Make the answer very short. 0.79. What is the ratio of the Survival Rate(%) of Malta in 2000 to that in 2010?
Your answer should be very brief. 1. What is the ratio of the Survival Rate(%) of Mauritius in 2000 to that in 2010?
Provide a succinct answer. 1. What is the ratio of the Survival Rate(%) in Morocco in 2000 to that in 2010?
Your answer should be very brief. 0.87. What is the ratio of the Survival Rate(%) of El Salvador in 2000 to that in 2011?
Provide a succinct answer. 0.79. What is the ratio of the Survival Rate(%) in Malta in 2000 to that in 2011?
Offer a terse response. 1.01. What is the ratio of the Survival Rate(%) in Mauritius in 2000 to that in 2011?
Offer a very short reply. 1. What is the ratio of the Survival Rate(%) of Morocco in 2000 to that in 2011?
Provide a short and direct response. 0.89. What is the ratio of the Survival Rate(%) in El Salvador in 2001 to that in 2002?
Give a very brief answer. 0.93. What is the ratio of the Survival Rate(%) in Malta in 2001 to that in 2002?
Make the answer very short. 1.01. What is the ratio of the Survival Rate(%) in Morocco in 2001 to that in 2002?
Your answer should be very brief. 1.04. What is the ratio of the Survival Rate(%) in El Salvador in 2001 to that in 2007?
Offer a very short reply. 0.87. What is the ratio of the Survival Rate(%) of Mauritius in 2001 to that in 2007?
Provide a short and direct response. 1.01. What is the ratio of the Survival Rate(%) in Morocco in 2001 to that in 2007?
Your response must be concise. 1.01. What is the ratio of the Survival Rate(%) of El Salvador in 2001 to that in 2008?
Keep it short and to the point. 0.87. What is the ratio of the Survival Rate(%) in Malta in 2001 to that in 2008?
Make the answer very short. 1.23. What is the ratio of the Survival Rate(%) in Morocco in 2001 to that in 2008?
Your answer should be very brief. 0.99. What is the ratio of the Survival Rate(%) in El Salvador in 2001 to that in 2010?
Ensure brevity in your answer.  0.79. What is the ratio of the Survival Rate(%) in Malta in 2001 to that in 2010?
Offer a very short reply. 1.01. What is the ratio of the Survival Rate(%) in Morocco in 2001 to that in 2010?
Keep it short and to the point. 0.9. What is the ratio of the Survival Rate(%) of El Salvador in 2001 to that in 2011?
Your answer should be very brief. 0.8. What is the ratio of the Survival Rate(%) in Malta in 2001 to that in 2011?
Your response must be concise. 1.02. What is the ratio of the Survival Rate(%) in Mauritius in 2001 to that in 2011?
Offer a very short reply. 0.99. What is the ratio of the Survival Rate(%) in Morocco in 2001 to that in 2011?
Provide a succinct answer. 0.91. What is the ratio of the Survival Rate(%) of El Salvador in 2002 to that in 2007?
Offer a terse response. 0.93. What is the ratio of the Survival Rate(%) of Mauritius in 2002 to that in 2007?
Make the answer very short. 1.02. What is the ratio of the Survival Rate(%) of Morocco in 2002 to that in 2007?
Give a very brief answer. 0.98. What is the ratio of the Survival Rate(%) in El Salvador in 2002 to that in 2008?
Provide a short and direct response. 0.93. What is the ratio of the Survival Rate(%) of Malta in 2002 to that in 2008?
Your answer should be compact. 1.22. What is the ratio of the Survival Rate(%) in Morocco in 2002 to that in 2008?
Offer a very short reply. 0.95. What is the ratio of the Survival Rate(%) in El Salvador in 2002 to that in 2010?
Make the answer very short. 0.85. What is the ratio of the Survival Rate(%) of Mauritius in 2002 to that in 2010?
Offer a terse response. 1. What is the ratio of the Survival Rate(%) of Morocco in 2002 to that in 2010?
Keep it short and to the point. 0.87. What is the ratio of the Survival Rate(%) of El Salvador in 2002 to that in 2011?
Your answer should be very brief. 0.86. What is the ratio of the Survival Rate(%) of Morocco in 2002 to that in 2011?
Give a very brief answer. 0.88. What is the ratio of the Survival Rate(%) in Malta in 2007 to that in 2008?
Give a very brief answer. 1.2. What is the ratio of the Survival Rate(%) of Mauritius in 2007 to that in 2008?
Your answer should be compact. 0.98. What is the ratio of the Survival Rate(%) in Morocco in 2007 to that in 2008?
Offer a terse response. 0.98. What is the ratio of the Survival Rate(%) in El Salvador in 2007 to that in 2010?
Give a very brief answer. 0.92. What is the ratio of the Survival Rate(%) in Malta in 2007 to that in 2010?
Offer a very short reply. 0.99. What is the ratio of the Survival Rate(%) in Mauritius in 2007 to that in 2010?
Your answer should be compact. 0.98. What is the ratio of the Survival Rate(%) of Morocco in 2007 to that in 2010?
Provide a short and direct response. 0.89. What is the ratio of the Survival Rate(%) in El Salvador in 2007 to that in 2011?
Provide a succinct answer. 0.92. What is the ratio of the Survival Rate(%) in Malta in 2007 to that in 2011?
Make the answer very short. 1. What is the ratio of the Survival Rate(%) of Mauritius in 2007 to that in 2011?
Keep it short and to the point. 0.98. What is the ratio of the Survival Rate(%) in Morocco in 2007 to that in 2011?
Give a very brief answer. 0.9. What is the ratio of the Survival Rate(%) of El Salvador in 2008 to that in 2010?
Ensure brevity in your answer.  0.92. What is the ratio of the Survival Rate(%) in Malta in 2008 to that in 2010?
Your answer should be compact. 0.82. What is the ratio of the Survival Rate(%) in Mauritius in 2008 to that in 2010?
Keep it short and to the point. 1. What is the ratio of the Survival Rate(%) of Morocco in 2008 to that in 2010?
Your answer should be compact. 0.91. What is the ratio of the Survival Rate(%) of El Salvador in 2008 to that in 2011?
Keep it short and to the point. 0.92. What is the ratio of the Survival Rate(%) in Malta in 2008 to that in 2011?
Make the answer very short. 0.83. What is the ratio of the Survival Rate(%) in Morocco in 2008 to that in 2011?
Offer a terse response. 0.92. What is the ratio of the Survival Rate(%) of El Salvador in 2010 to that in 2011?
Your answer should be very brief. 1.01. What is the ratio of the Survival Rate(%) in Malta in 2010 to that in 2011?
Provide a short and direct response. 1.01. What is the ratio of the Survival Rate(%) of Morocco in 2010 to that in 2011?
Provide a succinct answer. 1.02. What is the difference between the highest and the second highest Survival Rate(%) in El Salvador?
Provide a short and direct response. 0.48. What is the difference between the highest and the second highest Survival Rate(%) in Malta?
Provide a short and direct response. 1.1. What is the difference between the highest and the second highest Survival Rate(%) in Mauritius?
Keep it short and to the point. 0.1. What is the difference between the highest and the second highest Survival Rate(%) in Morocco?
Give a very brief answer. 1.44. What is the difference between the highest and the lowest Survival Rate(%) in El Salvador?
Your answer should be very brief. 19.14. What is the difference between the highest and the lowest Survival Rate(%) in Malta?
Offer a very short reply. 18.88. What is the difference between the highest and the lowest Survival Rate(%) in Mauritius?
Give a very brief answer. 1.9. What is the difference between the highest and the lowest Survival Rate(%) in Morocco?
Provide a succinct answer. 12.5. 